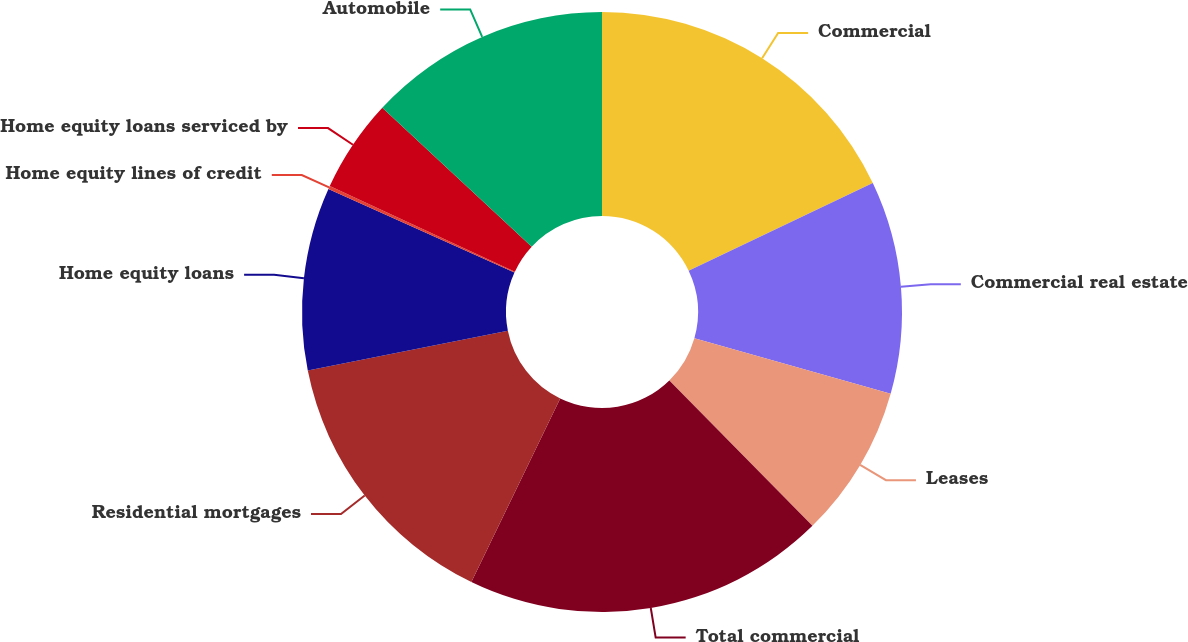Convert chart to OTSL. <chart><loc_0><loc_0><loc_500><loc_500><pie_chart><fcel>Commercial<fcel>Commercial real estate<fcel>Leases<fcel>Total commercial<fcel>Residential mortgages<fcel>Home equity loans<fcel>Home equity lines of credit<fcel>Home equity loans serviced by<fcel>Automobile<nl><fcel>17.92%<fcel>11.47%<fcel>8.24%<fcel>19.54%<fcel>14.7%<fcel>9.86%<fcel>0.17%<fcel>5.02%<fcel>13.08%<nl></chart> 